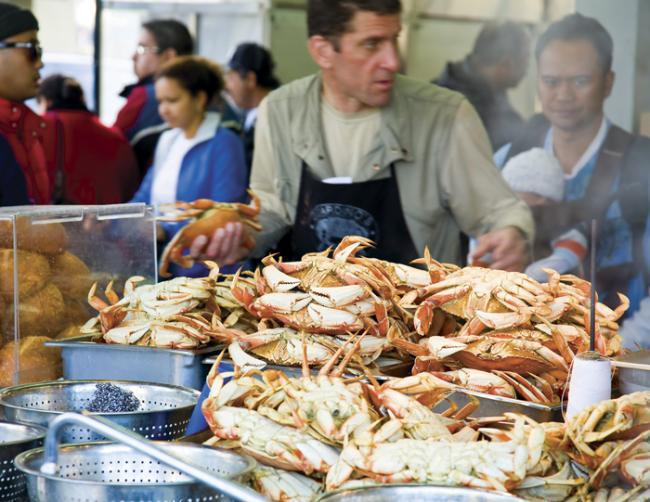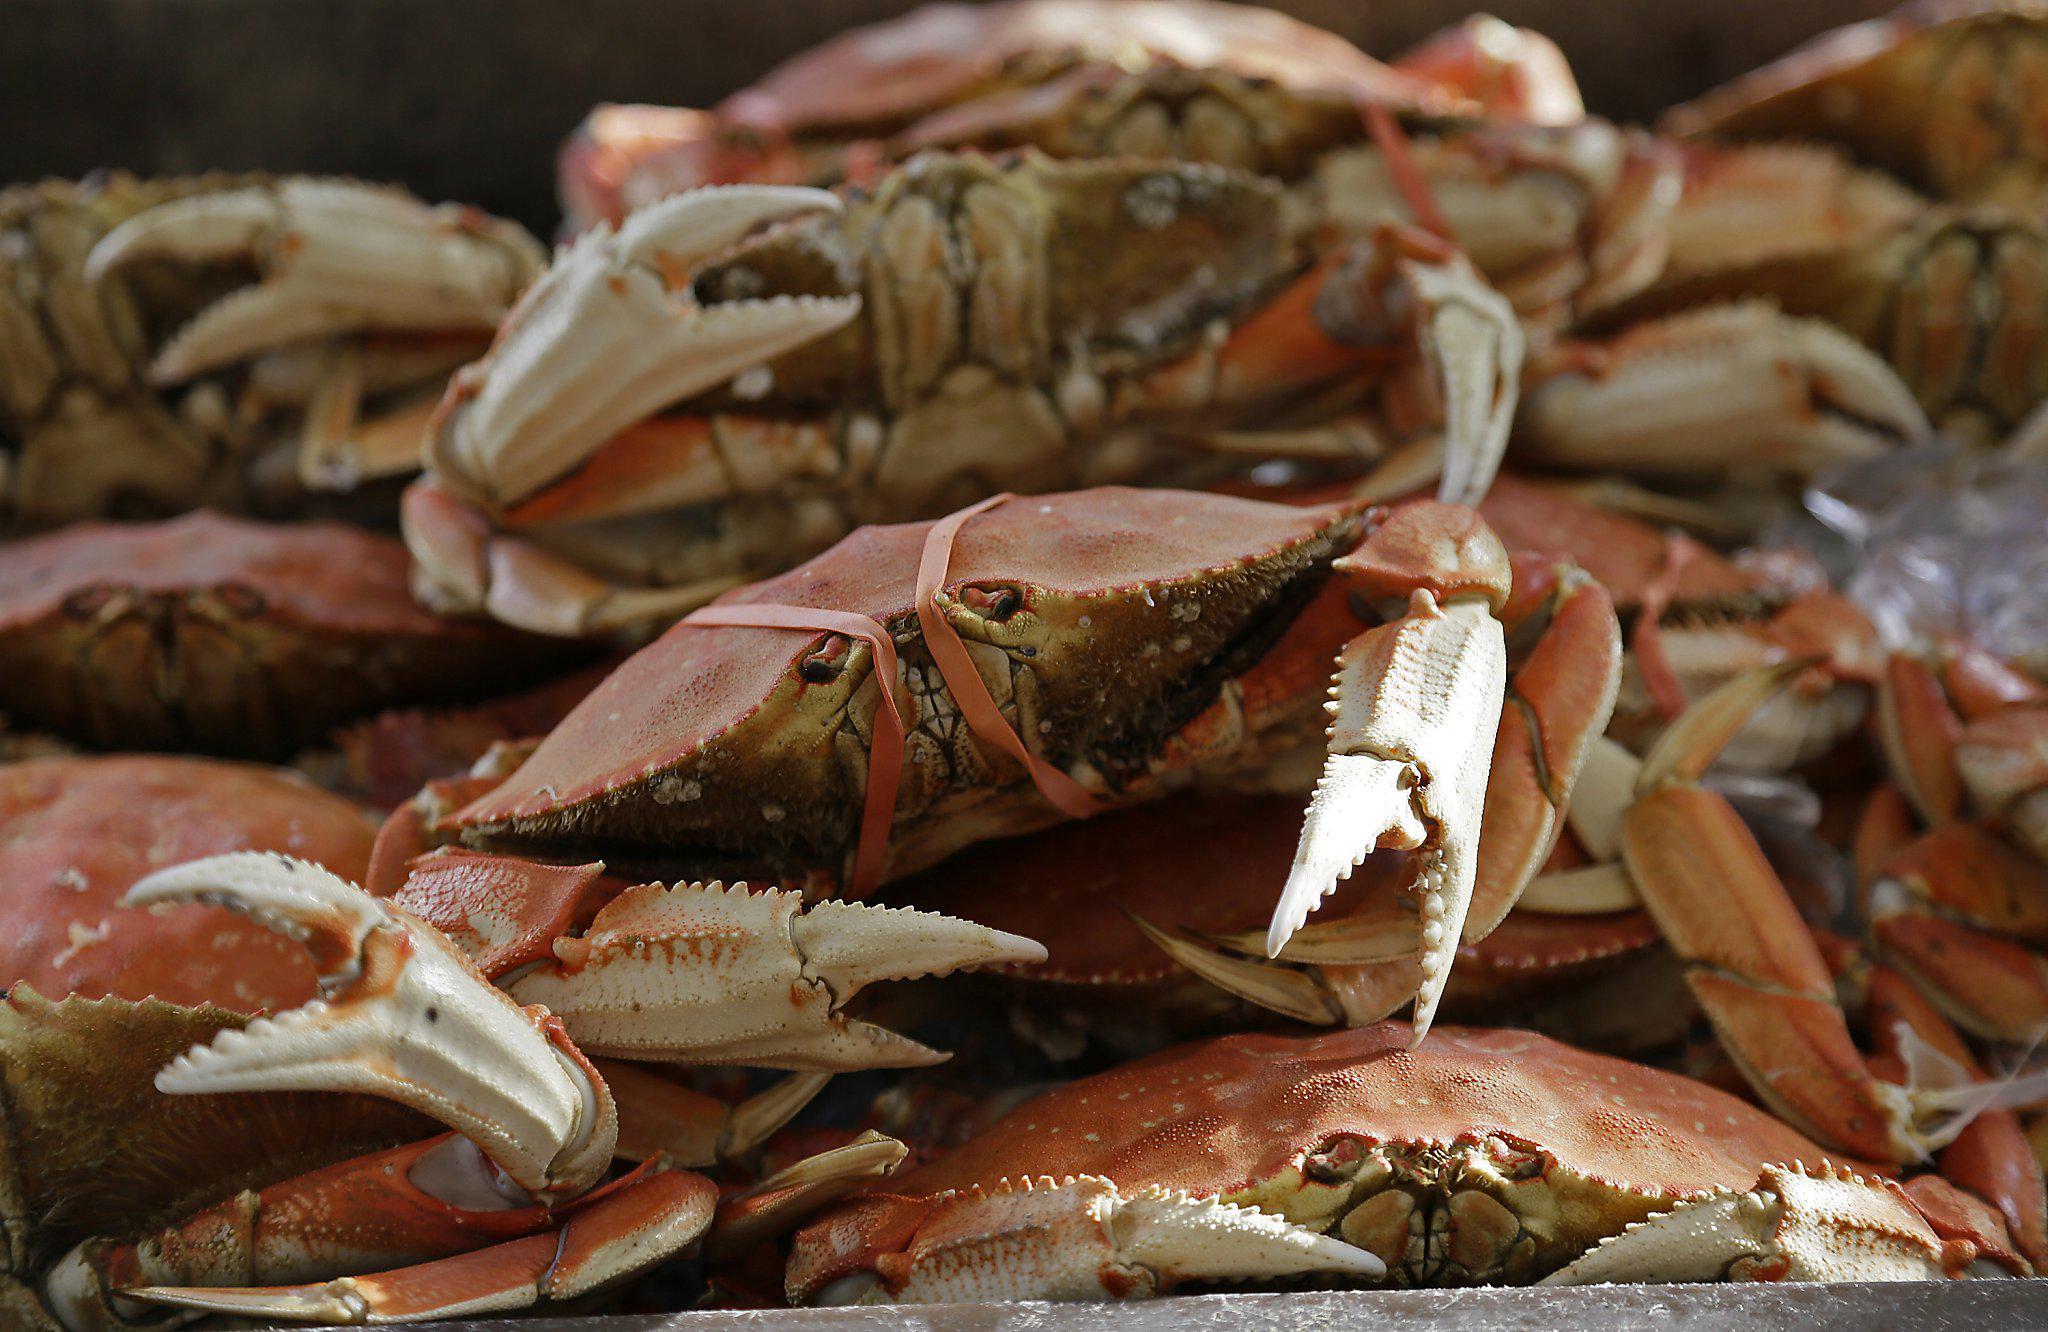The first image is the image on the left, the second image is the image on the right. Assess this claim about the two images: "In the left image, a man in an apron is behind a counter containing piles of upside-down crabs.". Correct or not? Answer yes or no. Yes. 